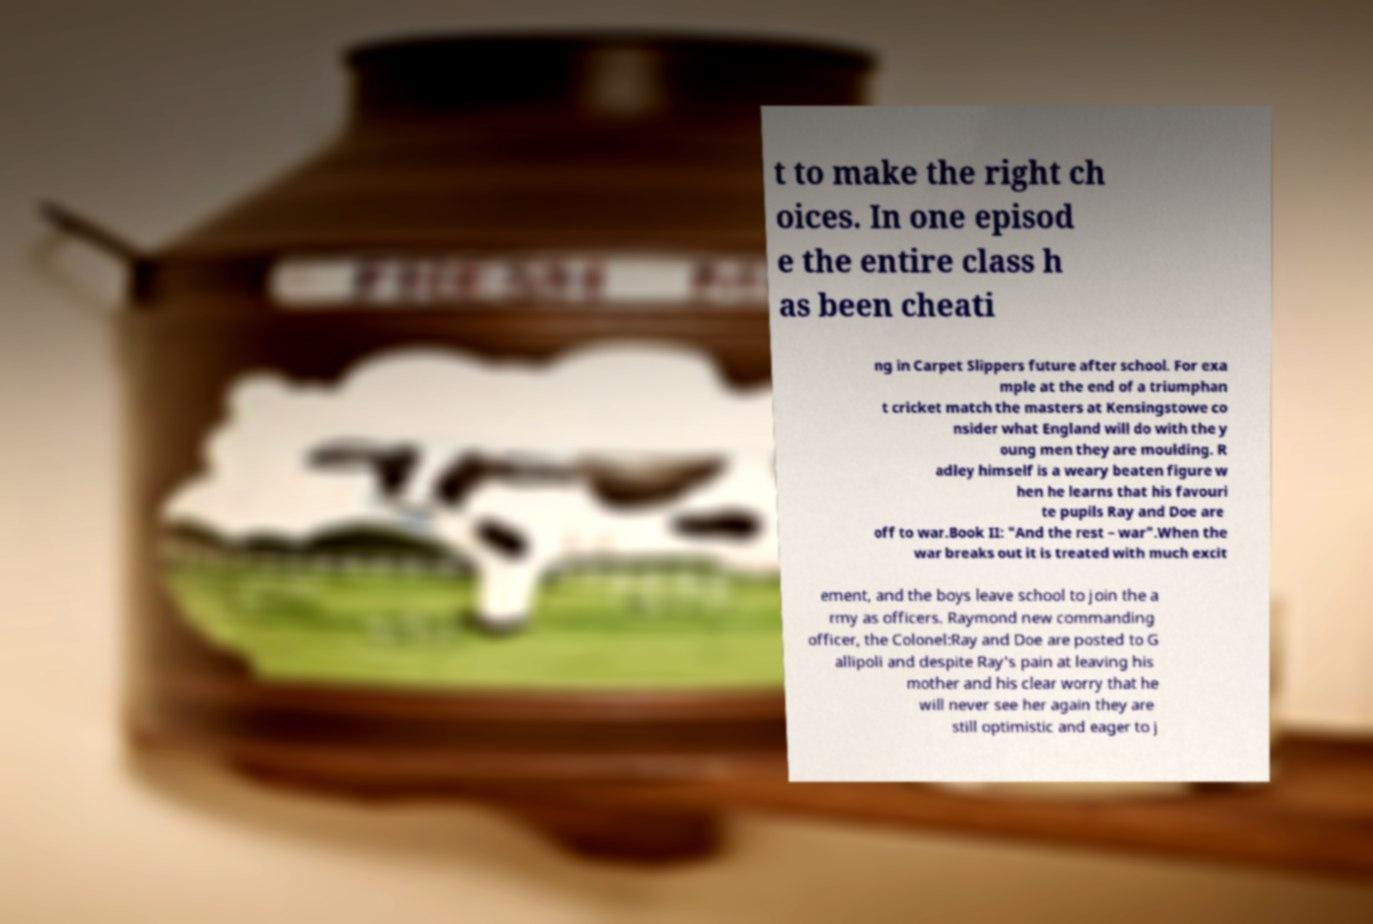There's text embedded in this image that I need extracted. Can you transcribe it verbatim? t to make the right ch oices. In one episod e the entire class h as been cheati ng in Carpet Slippers future after school. For exa mple at the end of a triumphan t cricket match the masters at Kensingstowe co nsider what England will do with the y oung men they are moulding. R adley himself is a weary beaten figure w hen he learns that his favouri te pupils Ray and Doe are off to war.Book II: "And the rest – war".When the war breaks out it is treated with much excit ement, and the boys leave school to join the a rmy as officers. Raymond new commanding officer, the Colonel:Ray and Doe are posted to G allipoli and despite Ray's pain at leaving his mother and his clear worry that he will never see her again they are still optimistic and eager to j 